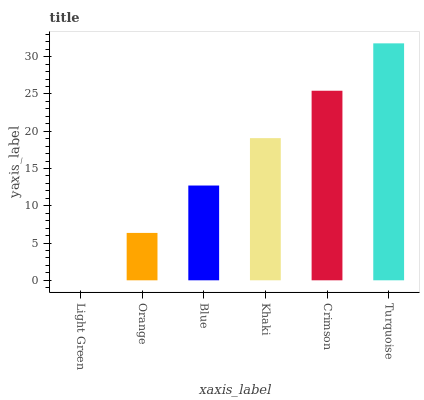Is Light Green the minimum?
Answer yes or no. Yes. Is Turquoise the maximum?
Answer yes or no. Yes. Is Orange the minimum?
Answer yes or no. No. Is Orange the maximum?
Answer yes or no. No. Is Orange greater than Light Green?
Answer yes or no. Yes. Is Light Green less than Orange?
Answer yes or no. Yes. Is Light Green greater than Orange?
Answer yes or no. No. Is Orange less than Light Green?
Answer yes or no. No. Is Khaki the high median?
Answer yes or no. Yes. Is Blue the low median?
Answer yes or no. Yes. Is Light Green the high median?
Answer yes or no. No. Is Khaki the low median?
Answer yes or no. No. 